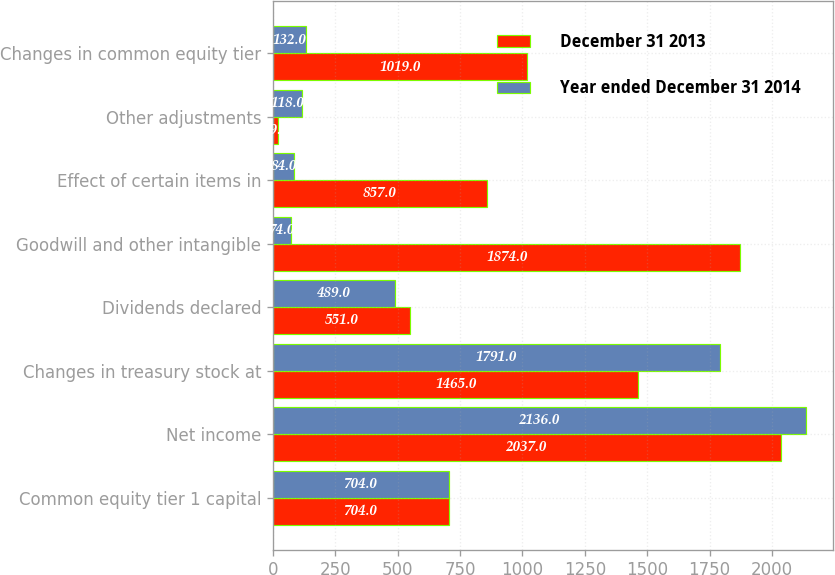Convert chart to OTSL. <chart><loc_0><loc_0><loc_500><loc_500><stacked_bar_chart><ecel><fcel>Common equity tier 1 capital<fcel>Net income<fcel>Changes in treasury stock at<fcel>Dividends declared<fcel>Goodwill and other intangible<fcel>Effect of certain items in<fcel>Other adjustments<fcel>Changes in common equity tier<nl><fcel>December 31 2013<fcel>704<fcel>2037<fcel>1465<fcel>551<fcel>1874<fcel>857<fcel>19<fcel>1019<nl><fcel>Year ended December 31 2014<fcel>704<fcel>2136<fcel>1791<fcel>489<fcel>74<fcel>84<fcel>118<fcel>132<nl></chart> 